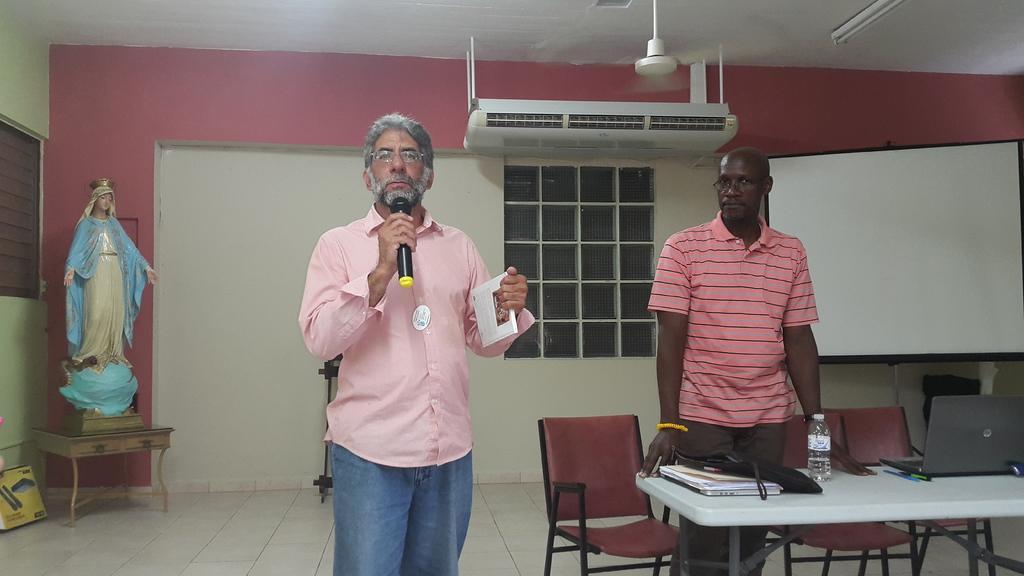Please provide a concise description of this image. in a room there is a goddess Mary sculpture at the corner and there is a man holding microphone speaking in it and holding paper in hand behind him there is another man standing in front of a table where there are so many books bag and water bottle, pens on it and a projector screen AC and fans rotating in the room. 